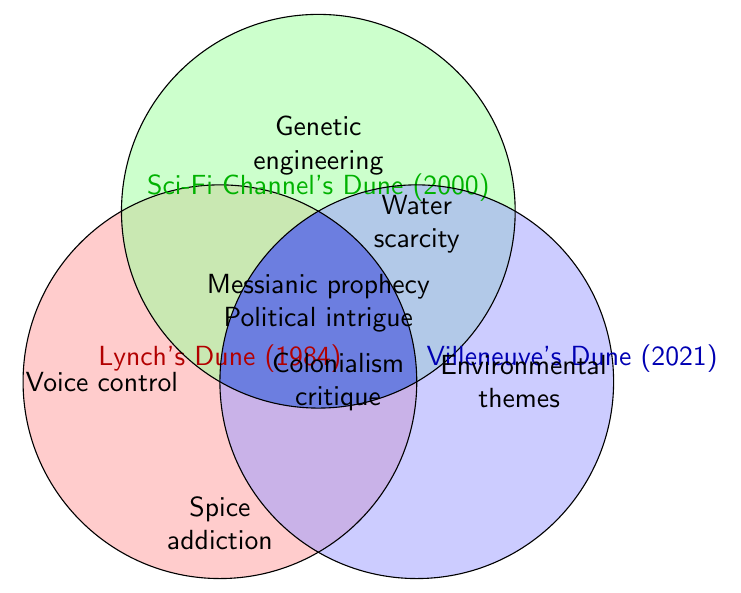How many themes are unique to Villeneuve's Dune (2021)? Look for themes only in the blue circle and count them: "Colonialism critique" and "Environmental themes".
Answer: 2 Which themes appear across all three adaptations? Find the themes located in the intersection of all three circles. These are "Messianic prophecy" and "Political intrigue".
Answer: Messianic prophecy, Political intrigue What themes are shared between Lynch's Dune (1984) and Sci-Fi Channel's Dune (2000)? Look for themes in the overlapping area between the red and green circles: "Messianic prophecy" and "Political intrigue".
Answer: Messianic prophecy, Political intrigue Which adaptation has the theme "Voice control"? Identify the theme "Voice control" and locate the circle it's in. It's in the red circle of Lynch's Dune (1984).
Answer: Lynch's Dune (1984) Are there any themes that "Spice addiction" shares with other adaptations? Locate "Spice addiction" in the red circle of Lynch's Dune (1984) and check if it overlaps with other circles. It does not overlap with any other circle.
Answer: No Which adaptation deals uniquely with "Genetic engineering"? Look at which circle the "Genetic engineering" theme falls into; it is only in the green circle of Sci-Fi Channel's Dune (2000).
Answer: Sci-Fi Channel's Dune (2000) How many total themes are represented in the figure? Count all the unique themes across the three circles: "Voice control", "Colonialism critique", "Water scarcity", "Spice addiction", "Environmental themes", "Genetic engineering", "Messianic prophecy", "Political intrigue". There are 8 unique themes.
Answer: 8 Which theme is the focus of all adaptations but not mentioned in Lynch's Dune (1984)? Find themes in the intersection of the green and blue circles but not present in the red circle. This includes "Water scarcity".
Answer: Water scarcity How many themes does each adaptation uniquely have? Count unique themes for each circle: Lynch's Dune (1984) has "Voice control" and "Spice addiction" (2), Villeneuve's Dune (2021) has "Colonialism critique" and "Environmental themes" (2), Sci-Fi Channel's Dune (2000) has "Water scarcity" and "Genetic engineering" (2).
Answer: 2, 2, 2 Is "Political intrigue" a common theme in both film adaptations of Dune? Check if "Political intrigue" appears within both the red and blue circles. It is shared among Lynch's Dune (1984) and Villeneuve's Dune (2021).
Answer: Yes 